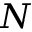Convert formula to latex. <formula><loc_0><loc_0><loc_500><loc_500>N</formula> 